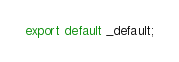Convert code to text. <code><loc_0><loc_0><loc_500><loc_500><_TypeScript_>export default _default;
</code> 